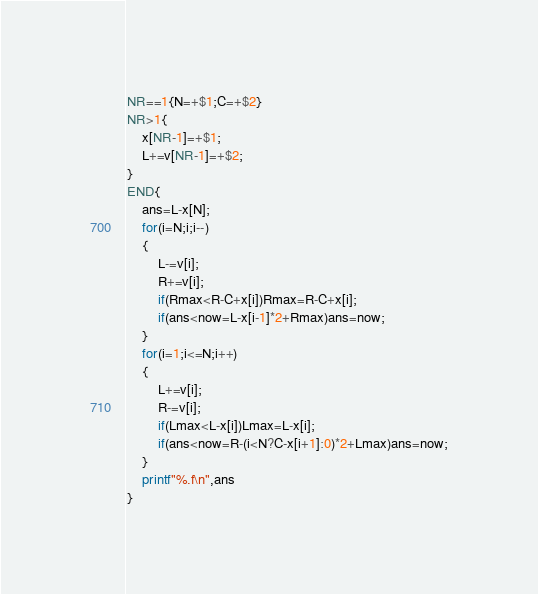<code> <loc_0><loc_0><loc_500><loc_500><_Awk_>NR==1{N=+$1;C=+$2}
NR>1{
	x[NR-1]=+$1;
	L+=v[NR-1]=+$2;
}
END{
	ans=L-x[N];
	for(i=N;i;i--)
	{
		L-=v[i];
		R+=v[i];
		if(Rmax<R-C+x[i])Rmax=R-C+x[i];
		if(ans<now=L-x[i-1]*2+Rmax)ans=now;
	}
	for(i=1;i<=N;i++)
	{
		L+=v[i];
		R-=v[i];
		if(Lmax<L-x[i])Lmax=L-x[i];
		if(ans<now=R-(i<N?C-x[i+1]:0)*2+Lmax)ans=now;
	}
	printf"%.f\n",ans
}</code> 